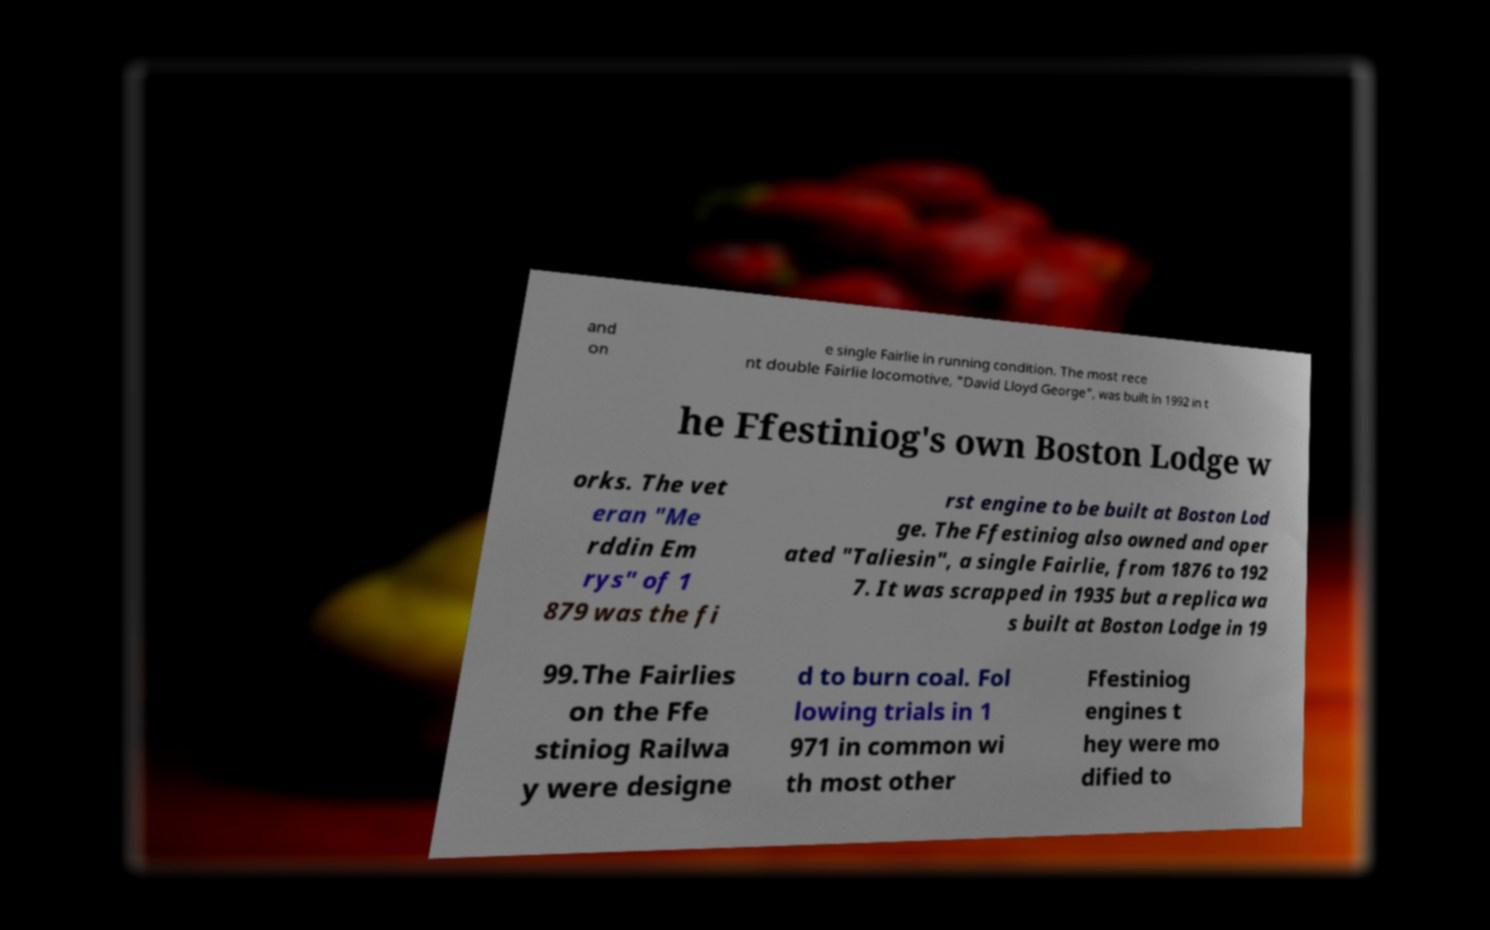Can you accurately transcribe the text from the provided image for me? and on e single Fairlie in running condition. The most rece nt double Fairlie locomotive, "David Lloyd George", was built in 1992 in t he Ffestiniog's own Boston Lodge w orks. The vet eran "Me rddin Em rys" of 1 879 was the fi rst engine to be built at Boston Lod ge. The Ffestiniog also owned and oper ated "Taliesin", a single Fairlie, from 1876 to 192 7. It was scrapped in 1935 but a replica wa s built at Boston Lodge in 19 99.The Fairlies on the Ffe stiniog Railwa y were designe d to burn coal. Fol lowing trials in 1 971 in common wi th most other Ffestiniog engines t hey were mo dified to 